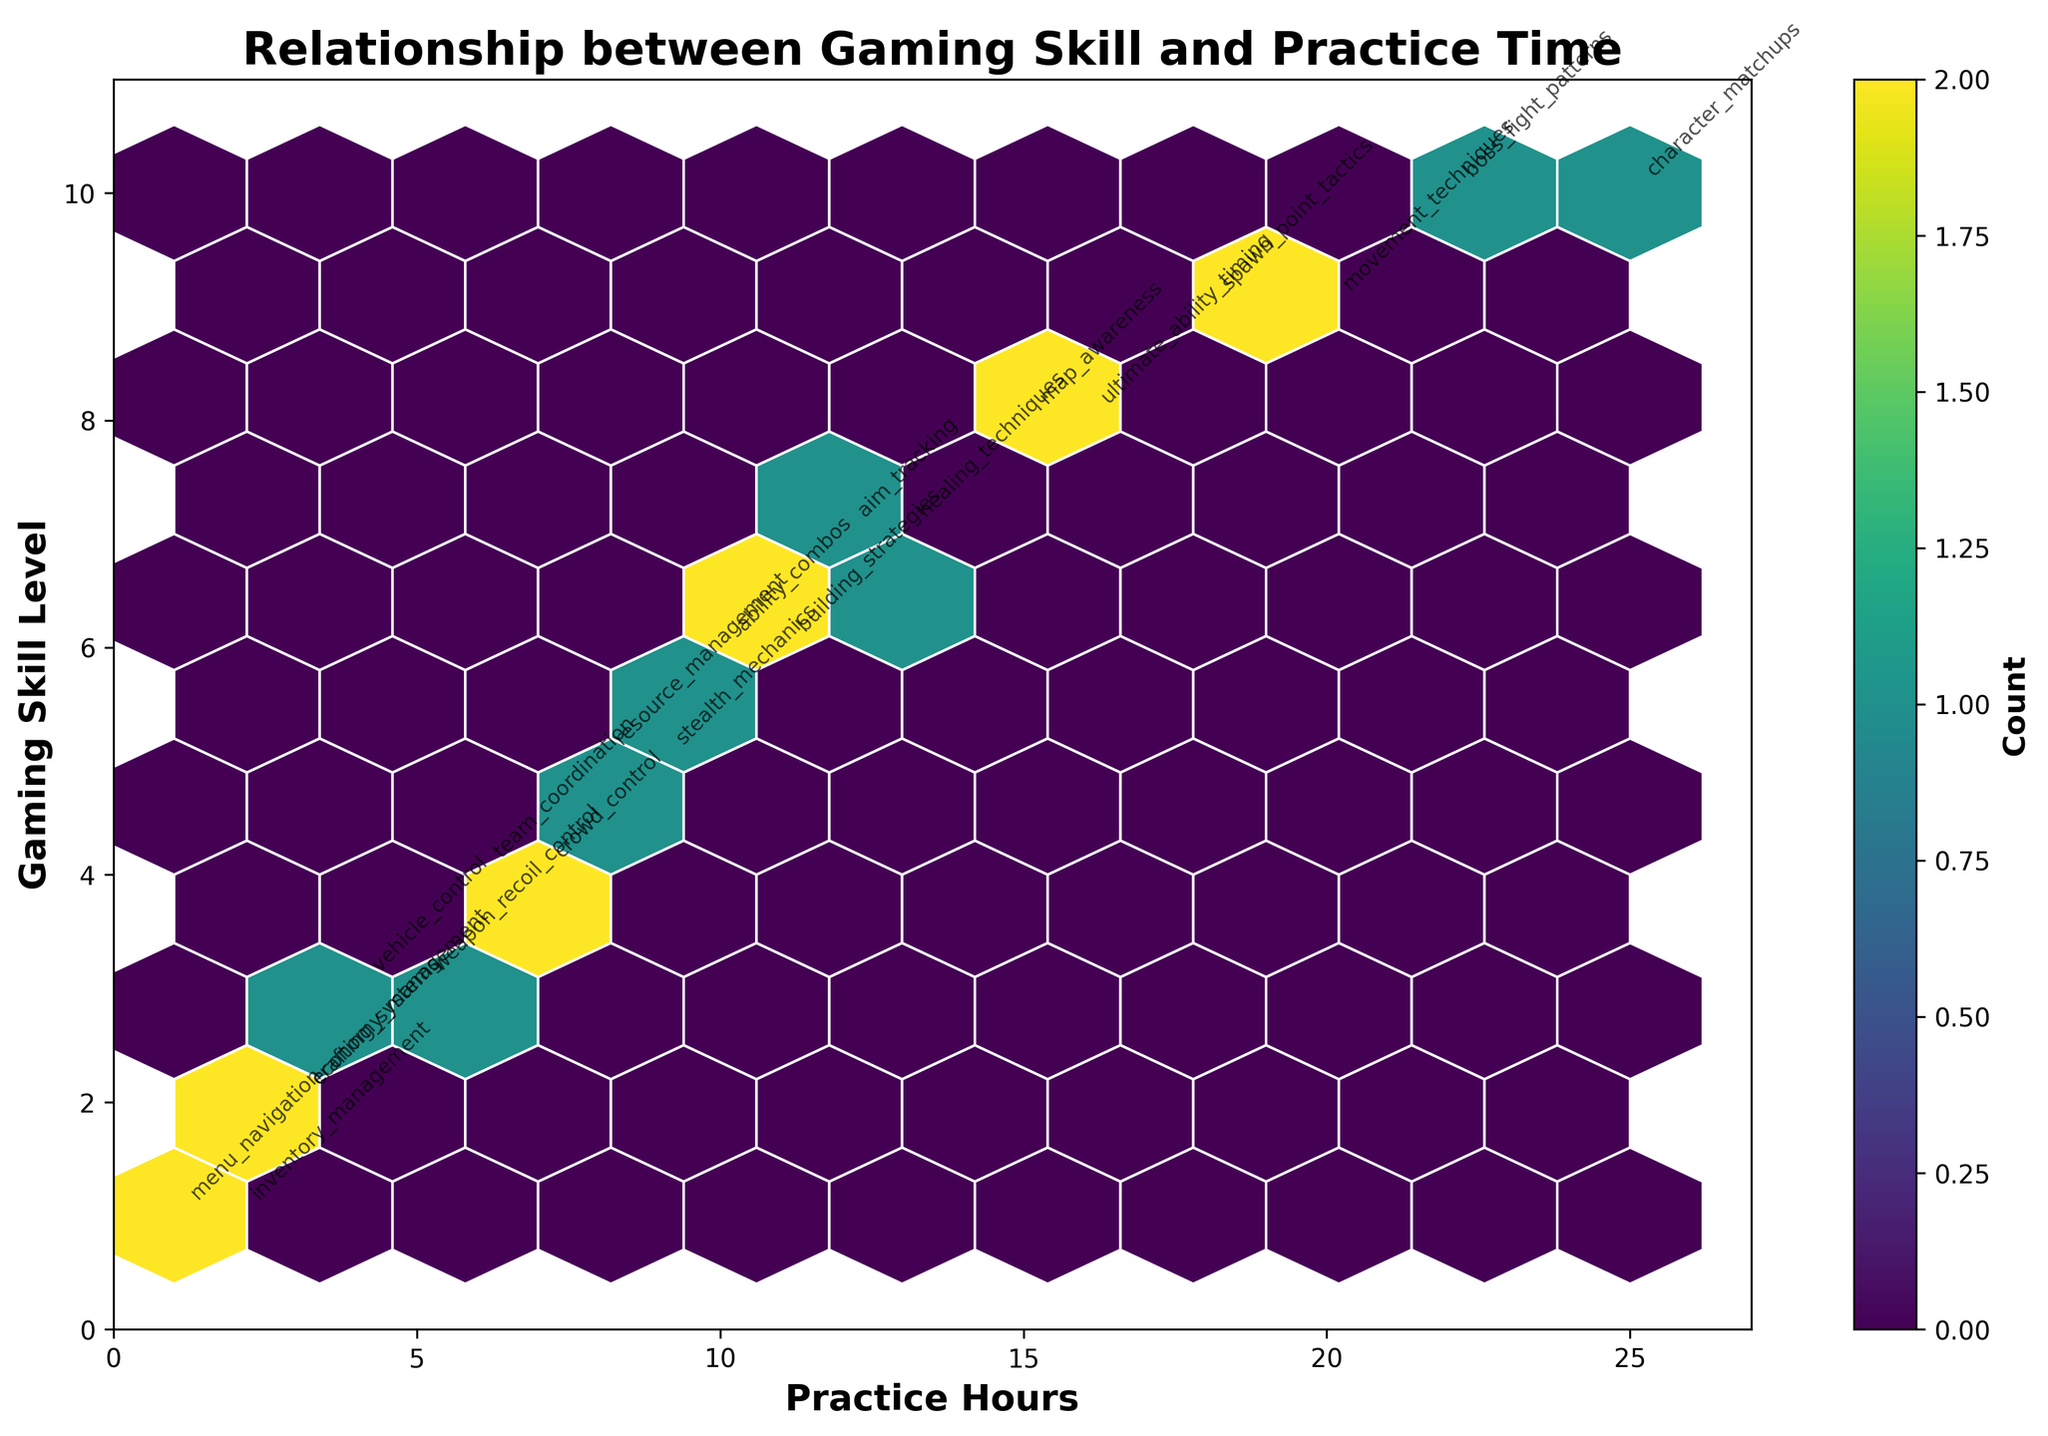What is the title of the plot? The title of the plot is located at the top and it describes the main relationship being displayed. In this case, it is "Relationship between Gaming Skill and Practice Time."
Answer: Relationship between Gaming Skill and Practice Time What does the color represent in the hexbin plot? The color in a hexbin plot represents the count of data points within each hexagonal bin. Darker colors indicate higher counts.
Answer: Count How many practice hours correspond to the highest gaming skill level (10)? By locating the point on the y-axis where the gaming skill level reaches 10 and finding the corresponding x-axis value, we can see it's at 25 practice hours.
Answer: 25 Which game mechanic has the lowest practice hours with a gaming skill level of 1? Identify the points where the gaming skill level is 1 on the y-axis, and then check the x-axis values to see which has the smallest value for practice hours and look at the mechanic label. It's "menu_navigation" with 1 practice hour.
Answer: menu_navigation Is there a trend between practice hours and gaming skill level? Observe the general direction of the points. If a trend is visible, it usually shows an overall increase in gaming skill level with increased practice hours. Here, there is an upward trend indicating a positive relationship.
Answer: Yes What is the average gaming skill level for practice hours greater than 10? Identify all points where practice hours are greater than 10, and then calculate the average of the corresponding gaming skill levels. The skill levels are 7, 8, 9, 8, 10, 7, 6, 10, 9. The average is (7+8+9+8+10+7+6+10+9) / 9 = 8.22.
Answer: 8.22 Which game mechanics are associated with the highest practice hours? Look for the highest values on the practice hours axis and identify the corresponding game mechanics from the annotations. The highest practice hours (25) are associated with "character_matchups."
Answer: character_matchups How many points have a practice time of exactly 10 hours? Visual examination of the plot reveals that the hexbin plot bins practice times and gaming skills, so check the relevant bin by finding the color indicating the count. Points at 10, 11, 12 practice hours are in one bin. Focusing on 10 practice hours, only one point (building_strategies) falls into this category.
Answer: 1 How does the color intensity change from lower to higher practice hours? Examine the plot from the lower end of the practice hours axis to the higher end. The color intensity generally increases, indicating higher counts of data points as practice hours increase.
Answer: Increases Which game mechanic is associated with the second-highest gaming skill level (9) and what are its practice hours? Look for points where the gaming skill level is 9 on the y-axis, and then find the corresponding practice hours on the x-axis. There are two points: "movement_techniques" at 20 practice hours and "spawn_point_tactics" at 18 practice hours. We want the latter one.
Answer: spawn_point_tactics at 18 hours 